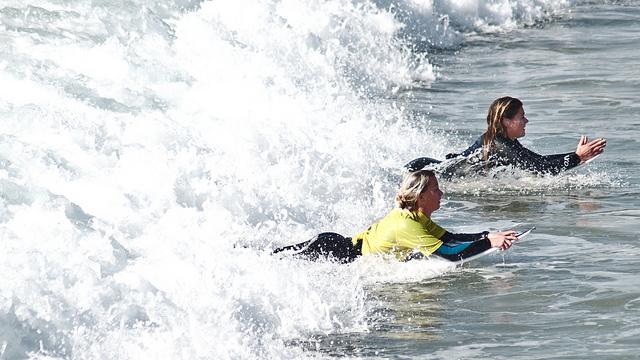Are they both wearing the same colors?
Write a very short answer. No. What color is the water?
Write a very short answer. White. What are the ladies doing?
Answer briefly. Surfing. 